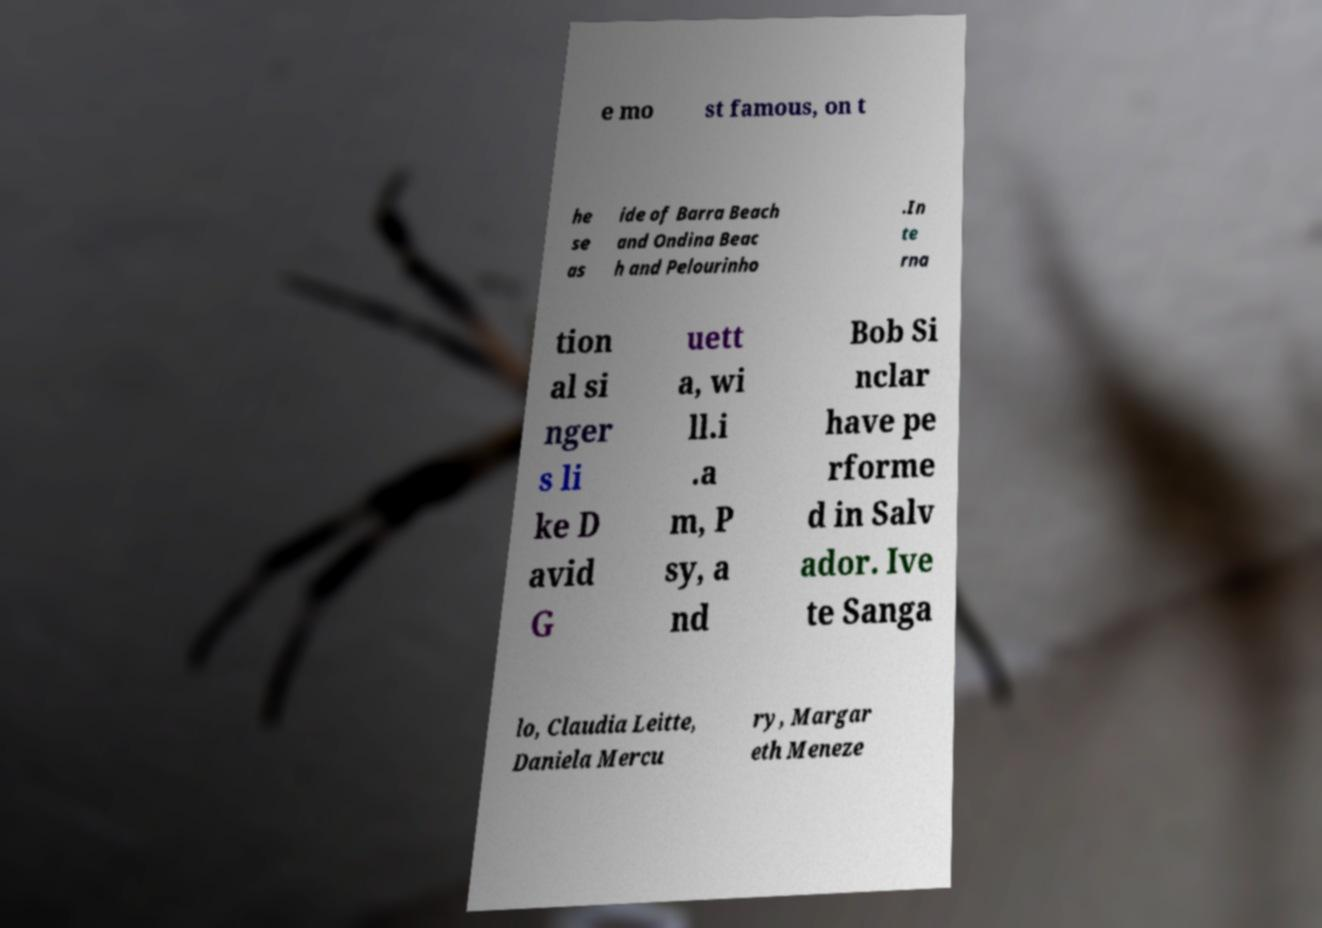What messages or text are displayed in this image? I need them in a readable, typed format. e mo st famous, on t he se as ide of Barra Beach and Ondina Beac h and Pelourinho .In te rna tion al si nger s li ke D avid G uett a, wi ll.i .a m, P sy, a nd Bob Si nclar have pe rforme d in Salv ador. Ive te Sanga lo, Claudia Leitte, Daniela Mercu ry, Margar eth Meneze 